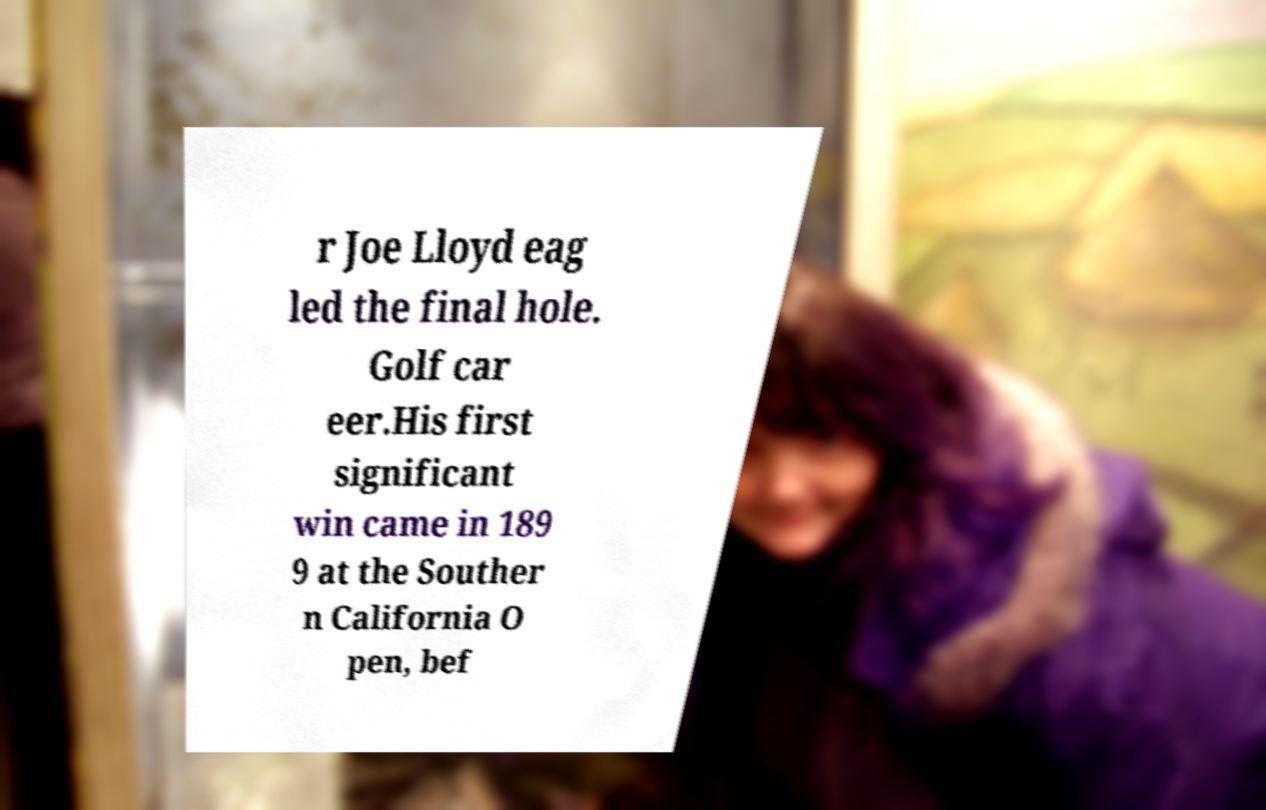Could you extract and type out the text from this image? r Joe Lloyd eag led the final hole. Golf car eer.His first significant win came in 189 9 at the Souther n California O pen, bef 